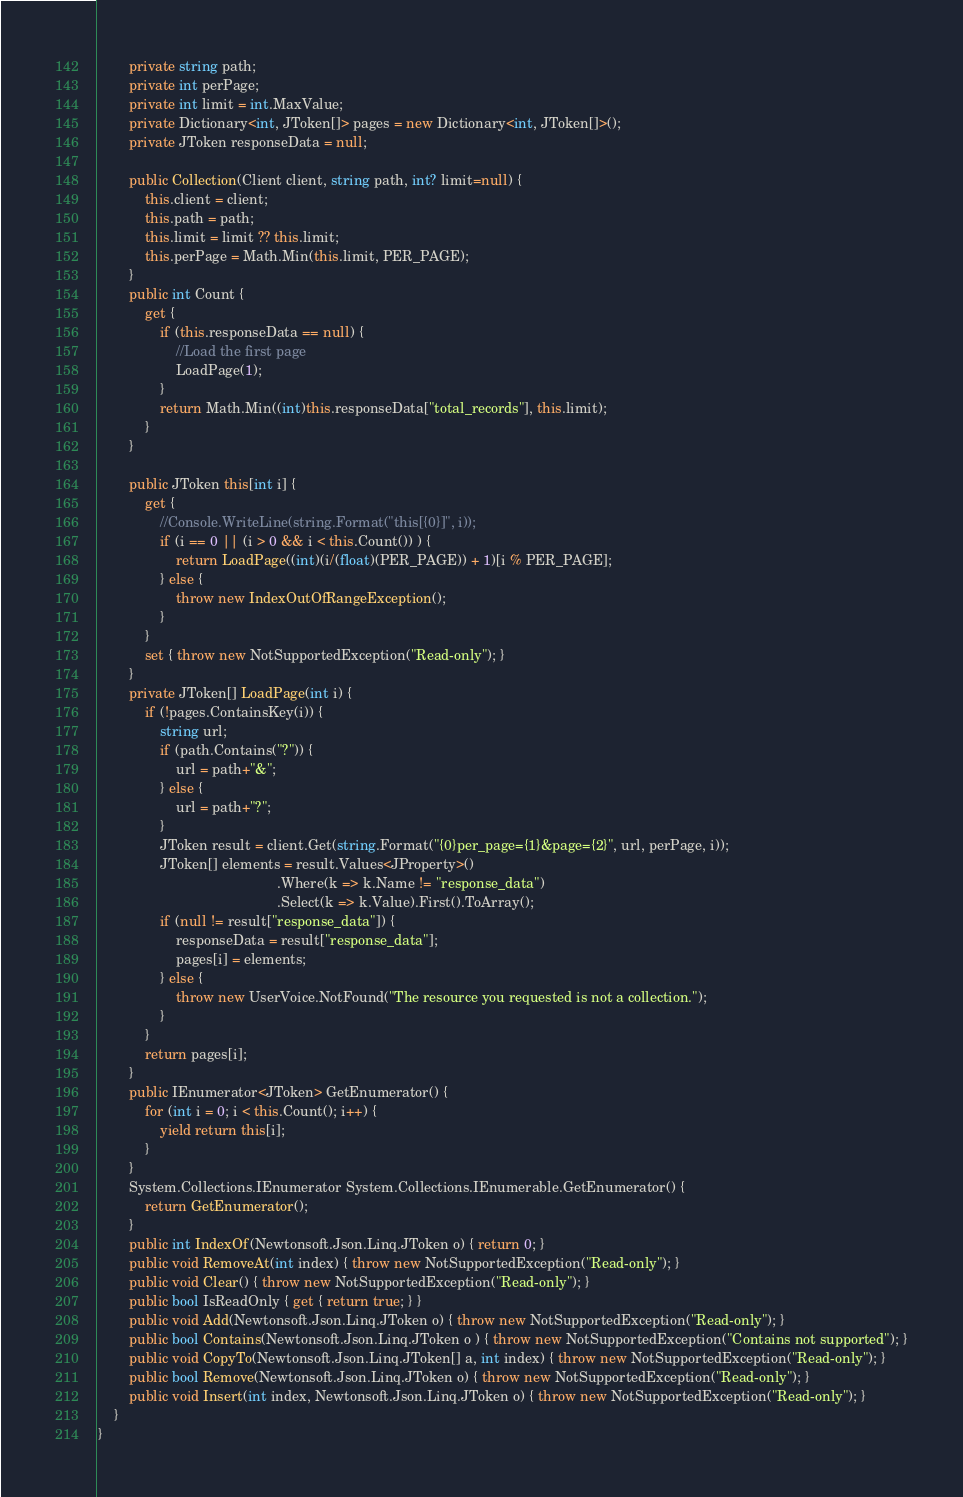<code> <loc_0><loc_0><loc_500><loc_500><_C#_>        private string path;
        private int perPage;
        private int limit = int.MaxValue;
        private Dictionary<int, JToken[]> pages = new Dictionary<int, JToken[]>();
        private JToken responseData = null;

        public Collection(Client client, string path, int? limit=null) {
            this.client = client;
            this.path = path;
            this.limit = limit ?? this.limit;
            this.perPage = Math.Min(this.limit, PER_PAGE);
        }
        public int Count {
            get {
                if (this.responseData == null) {
                    //Load the first page
                    LoadPage(1);
                }
                return Math.Min((int)this.responseData["total_records"], this.limit);
            }
        }

        public JToken this[int i] {
            get {
                //Console.WriteLine(string.Format("this[{0}]", i));
                if (i == 0 || (i > 0 && i < this.Count()) ) {
                    return LoadPage((int)(i/(float)(PER_PAGE)) + 1)[i % PER_PAGE];
                } else {
                    throw new IndexOutOfRangeException();
                }
            }
            set { throw new NotSupportedException("Read-only"); }
        }
        private JToken[] LoadPage(int i) {
            if (!pages.ContainsKey(i)) {
                string url;
                if (path.Contains("?")) {
                    url = path+"&";
                } else {
                    url = path+"?";
                }
                JToken result = client.Get(string.Format("{0}per_page={1}&page={2}", url, perPage, i));
                JToken[] elements = result.Values<JProperty>()
                                              .Where(k => k.Name != "response_data")
                                              .Select(k => k.Value).First().ToArray();
                if (null != result["response_data"]) {
                    responseData = result["response_data"];
                    pages[i] = elements;
                } else {
                    throw new UserVoice.NotFound("The resource you requested is not a collection.");
                }
            }
            return pages[i];
        }
        public IEnumerator<JToken> GetEnumerator() {
            for (int i = 0; i < this.Count(); i++) {
                yield return this[i];
            }
        }
        System.Collections.IEnumerator System.Collections.IEnumerable.GetEnumerator() {
            return GetEnumerator();
        }
        public int IndexOf(Newtonsoft.Json.Linq.JToken o) { return 0; }
        public void RemoveAt(int index) { throw new NotSupportedException("Read-only"); }
        public void Clear() { throw new NotSupportedException("Read-only"); }
        public bool IsReadOnly { get { return true; } }
        public void Add(Newtonsoft.Json.Linq.JToken o) { throw new NotSupportedException("Read-only"); }
        public bool Contains(Newtonsoft.Json.Linq.JToken o ) { throw new NotSupportedException("Contains not supported"); }
        public void CopyTo(Newtonsoft.Json.Linq.JToken[] a, int index) { throw new NotSupportedException("Read-only"); }
        public bool Remove(Newtonsoft.Json.Linq.JToken o) { throw new NotSupportedException("Read-only"); }
        public void Insert(int index, Newtonsoft.Json.Linq.JToken o) { throw new NotSupportedException("Read-only"); }
    }
}</code> 